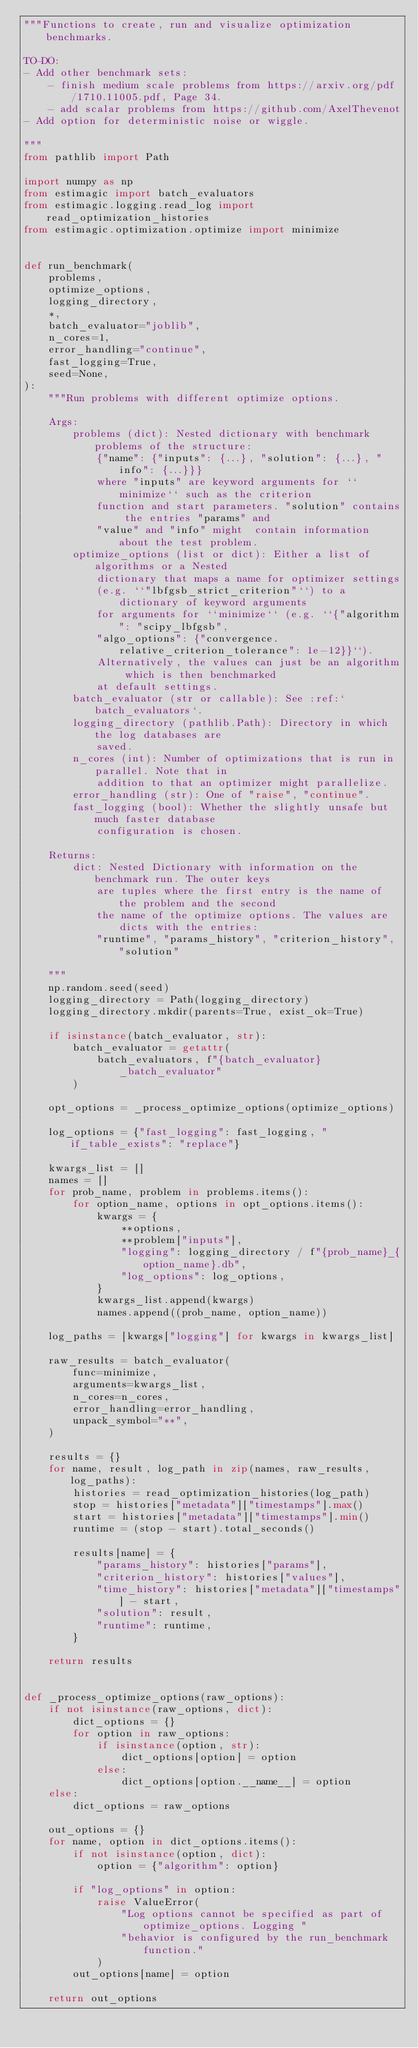<code> <loc_0><loc_0><loc_500><loc_500><_Python_>"""Functions to create, run and visualize optimization benchmarks.

TO-DO:
- Add other benchmark sets:
    - finish medium scale problems from https://arxiv.org/pdf/1710.11005.pdf, Page 34.
    - add scalar problems from https://github.com/AxelThevenot
- Add option for deterministic noise or wiggle.

"""
from pathlib import Path

import numpy as np
from estimagic import batch_evaluators
from estimagic.logging.read_log import read_optimization_histories
from estimagic.optimization.optimize import minimize


def run_benchmark(
    problems,
    optimize_options,
    logging_directory,
    *,
    batch_evaluator="joblib",
    n_cores=1,
    error_handling="continue",
    fast_logging=True,
    seed=None,
):
    """Run problems with different optimize options.

    Args:
        problems (dict): Nested dictionary with benchmark problems of the structure:
            {"name": {"inputs": {...}, "solution": {...}, "info": {...}}}
            where "inputs" are keyword arguments for ``minimize`` such as the criterion
            function and start parameters. "solution" contains the entries "params" and
            "value" and "info" might  contain information about the test problem.
        optimize_options (list or dict): Either a list of algorithms or a Nested
            dictionary that maps a name for optimizer settings
            (e.g. ``"lbfgsb_strict_criterion"``) to a dictionary of keyword arguments
            for arguments for ``minimize`` (e.g. ``{"algorithm": "scipy_lbfgsb",
            "algo_options": {"convergence.relative_criterion_tolerance": 1e-12}}``).
            Alternatively, the values can just be an algorithm which is then benchmarked
            at default settings.
        batch_evaluator (str or callable): See :ref:`batch_evaluators`.
        logging_directory (pathlib.Path): Directory in which the log databases are
            saved.
        n_cores (int): Number of optimizations that is run in parallel. Note that in
            addition to that an optimizer might parallelize.
        error_handling (str): One of "raise", "continue".
        fast_logging (bool): Whether the slightly unsafe but much faster database
            configuration is chosen.

    Returns:
        dict: Nested Dictionary with information on the benchmark run. The outer keys
            are tuples where the first entry is the name of the problem and the second
            the name of the optimize options. The values are dicts with the entries:
            "runtime", "params_history", "criterion_history", "solution"

    """
    np.random.seed(seed)
    logging_directory = Path(logging_directory)
    logging_directory.mkdir(parents=True, exist_ok=True)

    if isinstance(batch_evaluator, str):
        batch_evaluator = getattr(
            batch_evaluators, f"{batch_evaluator}_batch_evaluator"
        )

    opt_options = _process_optimize_options(optimize_options)

    log_options = {"fast_logging": fast_logging, "if_table_exists": "replace"}

    kwargs_list = []
    names = []
    for prob_name, problem in problems.items():
        for option_name, options in opt_options.items():
            kwargs = {
                **options,
                **problem["inputs"],
                "logging": logging_directory / f"{prob_name}_{option_name}.db",
                "log_options": log_options,
            }
            kwargs_list.append(kwargs)
            names.append((prob_name, option_name))

    log_paths = [kwargs["logging"] for kwargs in kwargs_list]

    raw_results = batch_evaluator(
        func=minimize,
        arguments=kwargs_list,
        n_cores=n_cores,
        error_handling=error_handling,
        unpack_symbol="**",
    )

    results = {}
    for name, result, log_path in zip(names, raw_results, log_paths):
        histories = read_optimization_histories(log_path)
        stop = histories["metadata"]["timestamps"].max()
        start = histories["metadata"]["timestamps"].min()
        runtime = (stop - start).total_seconds()

        results[name] = {
            "params_history": histories["params"],
            "criterion_history": histories["values"],
            "time_history": histories["metadata"]["timestamps"] - start,
            "solution": result,
            "runtime": runtime,
        }

    return results


def _process_optimize_options(raw_options):
    if not isinstance(raw_options, dict):
        dict_options = {}
        for option in raw_options:
            if isinstance(option, str):
                dict_options[option] = option
            else:
                dict_options[option.__name__] = option
    else:
        dict_options = raw_options

    out_options = {}
    for name, option in dict_options.items():
        if not isinstance(option, dict):
            option = {"algorithm": option}

        if "log_options" in option:
            raise ValueError(
                "Log options cannot be specified as part of optimize_options. Logging "
                "behavior is configured by the run_benchmark function."
            )
        out_options[name] = option

    return out_options
</code> 